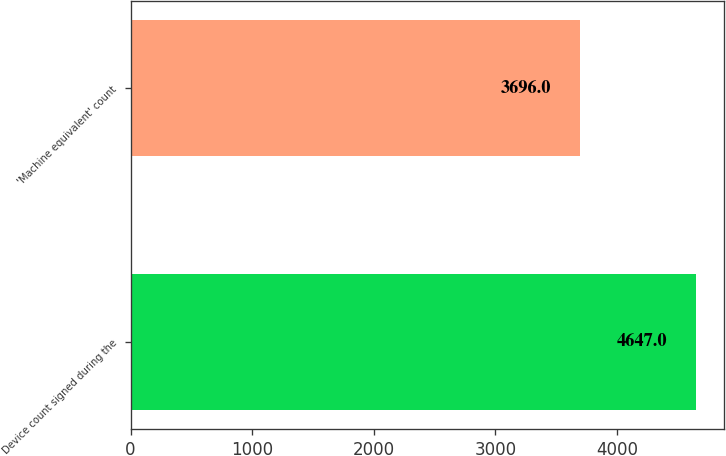Convert chart to OTSL. <chart><loc_0><loc_0><loc_500><loc_500><bar_chart><fcel>Device count signed during the<fcel>'Machine equivalent' count<nl><fcel>4647<fcel>3696<nl></chart> 